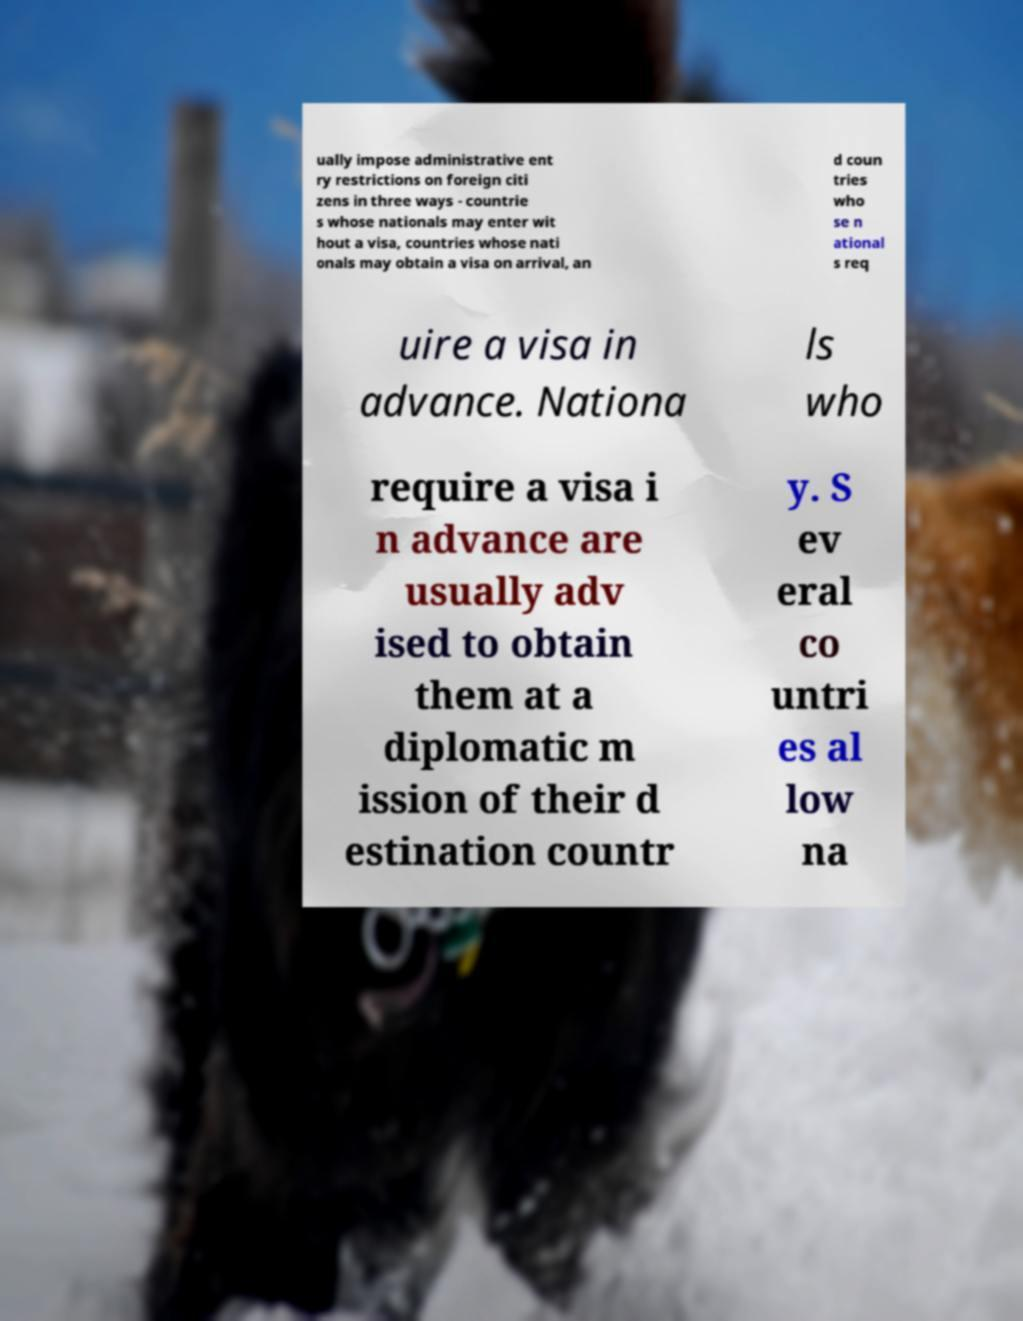I need the written content from this picture converted into text. Can you do that? ually impose administrative ent ry restrictions on foreign citi zens in three ways - countrie s whose nationals may enter wit hout a visa, countries whose nati onals may obtain a visa on arrival, an d coun tries who se n ational s req uire a visa in advance. Nationa ls who require a visa i n advance are usually adv ised to obtain them at a diplomatic m ission of their d estination countr y. S ev eral co untri es al low na 